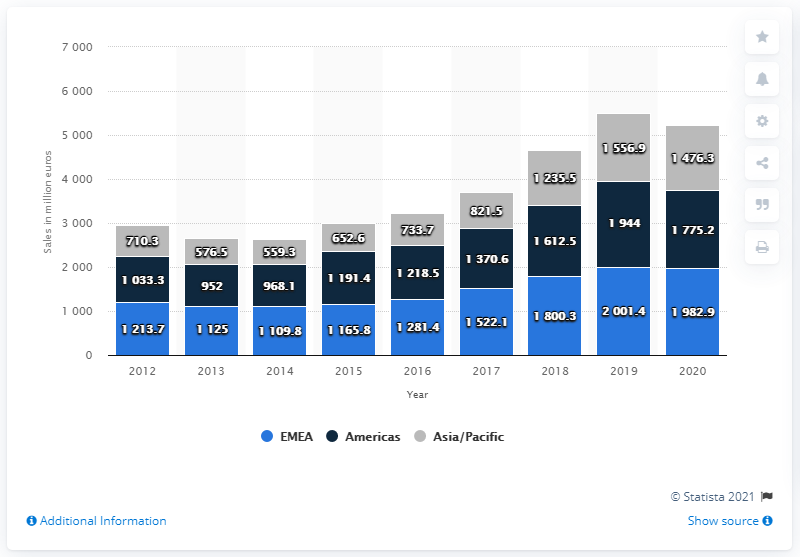Mention a couple of crucial points in this snapshot. In 2020, Puma announced worldwide sales of 5.2 billion euros. 